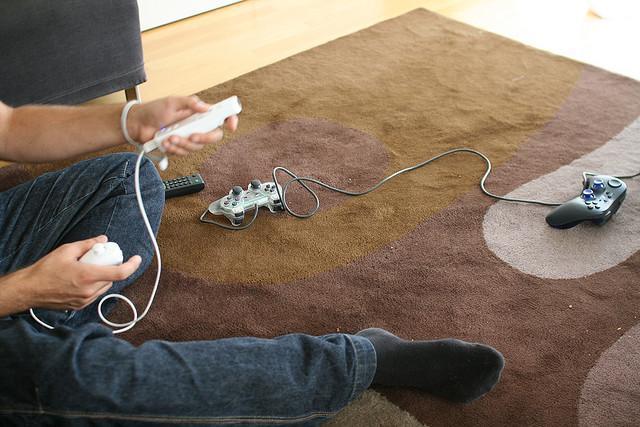How many remotes are there?
Give a very brief answer. 2. How many horses are in the picture?
Give a very brief answer. 0. 